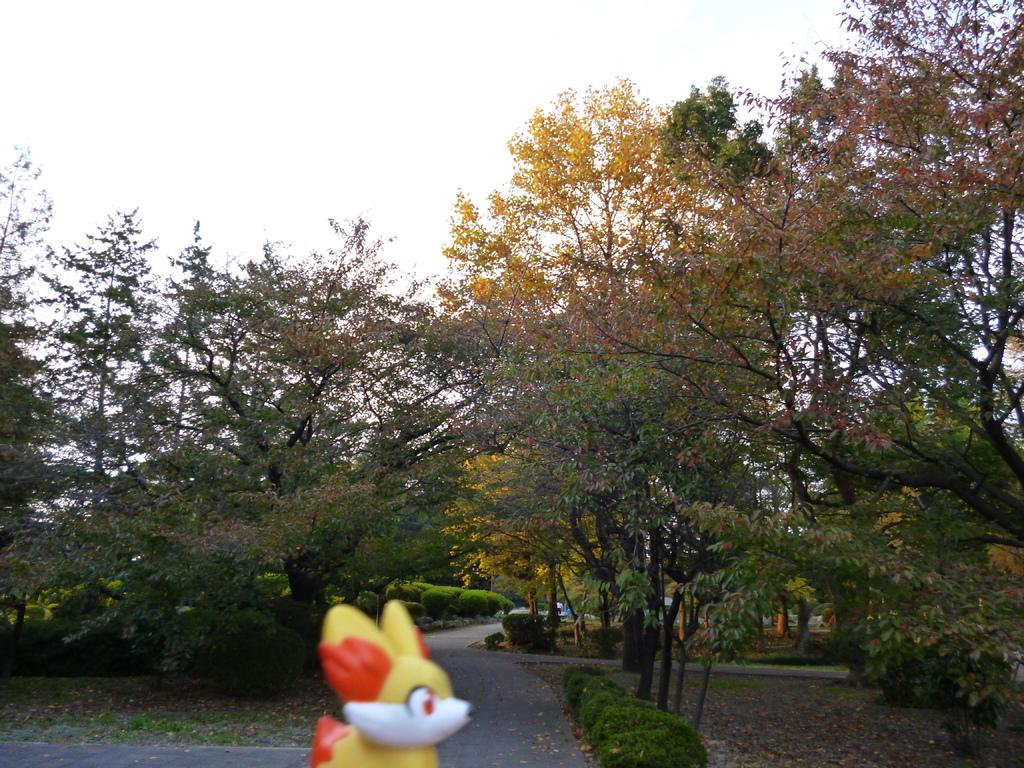Where was the image taken? The image was clicked outside. What can be seen in the middle of the image? There are trees in the middle of the image. What object is located at the bottom of the image? There is a toy at the bottom of the image. What is visible at the top of the image? The sky is visible at the top of the image. How many shoes are hanging from the trees in the image? There are no shoes hanging from the trees in the image; only trees are present. What type of yak can be seen grazing in the background of the image? There is no yak present in the image; it only features trees and a toy. 